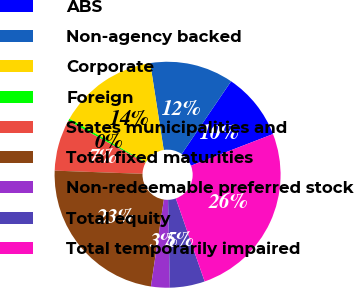Convert chart to OTSL. <chart><loc_0><loc_0><loc_500><loc_500><pie_chart><fcel>ABS<fcel>Non-agency backed<fcel>Corporate<fcel>Foreign<fcel>States municipalities and<fcel>Total fixed maturities<fcel>Non-redeemable preferred stock<fcel>Total equity<fcel>Total temporarily impaired<nl><fcel>9.64%<fcel>11.96%<fcel>14.29%<fcel>0.35%<fcel>7.32%<fcel>23.22%<fcel>2.68%<fcel>5.0%<fcel>25.54%<nl></chart> 